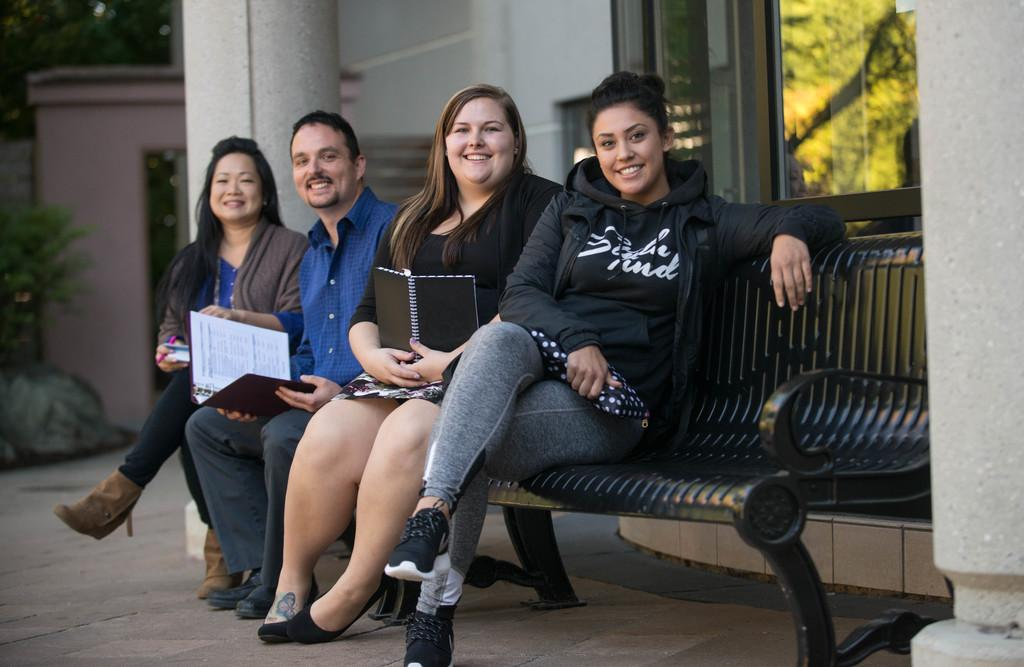What are the people in the image doing? There is a group of people sitting on a bench in the image. What are the people holding in their hands? The people are holding books and other objects in the image. What can be seen in the background of the image? There is a building and trees in the image. What is the reflection of in the window? The reflection of trees is visible in a window in the image. What type of punishment is being administered to the person in the image? There is no indication of punishment in the image; it shows a group of people sitting on a bench holding books and other objects. What is the picture of inside the picture frame in the image? There is no picture frame present in the image. 